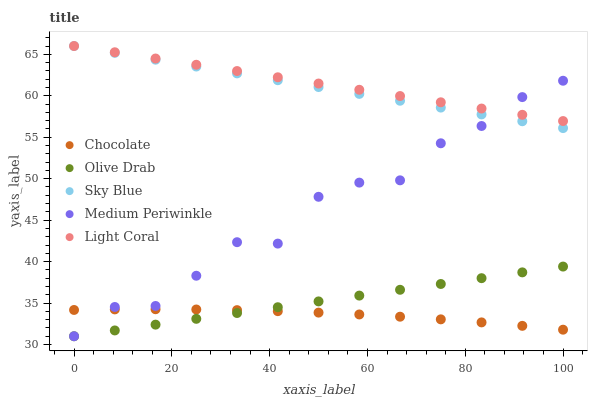Does Chocolate have the minimum area under the curve?
Answer yes or no. Yes. Does Light Coral have the maximum area under the curve?
Answer yes or no. Yes. Does Sky Blue have the minimum area under the curve?
Answer yes or no. No. Does Sky Blue have the maximum area under the curve?
Answer yes or no. No. Is Olive Drab the smoothest?
Answer yes or no. Yes. Is Medium Periwinkle the roughest?
Answer yes or no. Yes. Is Sky Blue the smoothest?
Answer yes or no. No. Is Sky Blue the roughest?
Answer yes or no. No. Does Medium Periwinkle have the lowest value?
Answer yes or no. Yes. Does Sky Blue have the lowest value?
Answer yes or no. No. Does Sky Blue have the highest value?
Answer yes or no. Yes. Does Medium Periwinkle have the highest value?
Answer yes or no. No. Is Olive Drab less than Light Coral?
Answer yes or no. Yes. Is Light Coral greater than Olive Drab?
Answer yes or no. Yes. Does Olive Drab intersect Medium Periwinkle?
Answer yes or no. Yes. Is Olive Drab less than Medium Periwinkle?
Answer yes or no. No. Is Olive Drab greater than Medium Periwinkle?
Answer yes or no. No. Does Olive Drab intersect Light Coral?
Answer yes or no. No. 